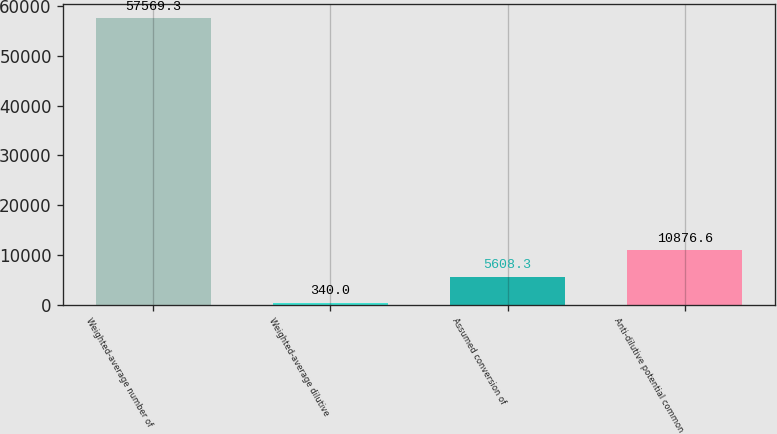<chart> <loc_0><loc_0><loc_500><loc_500><bar_chart><fcel>Weighted-average number of<fcel>Weighted-average dilutive<fcel>Assumed conversion of<fcel>Anti-dilutive potential common<nl><fcel>57569.3<fcel>340<fcel>5608.3<fcel>10876.6<nl></chart> 